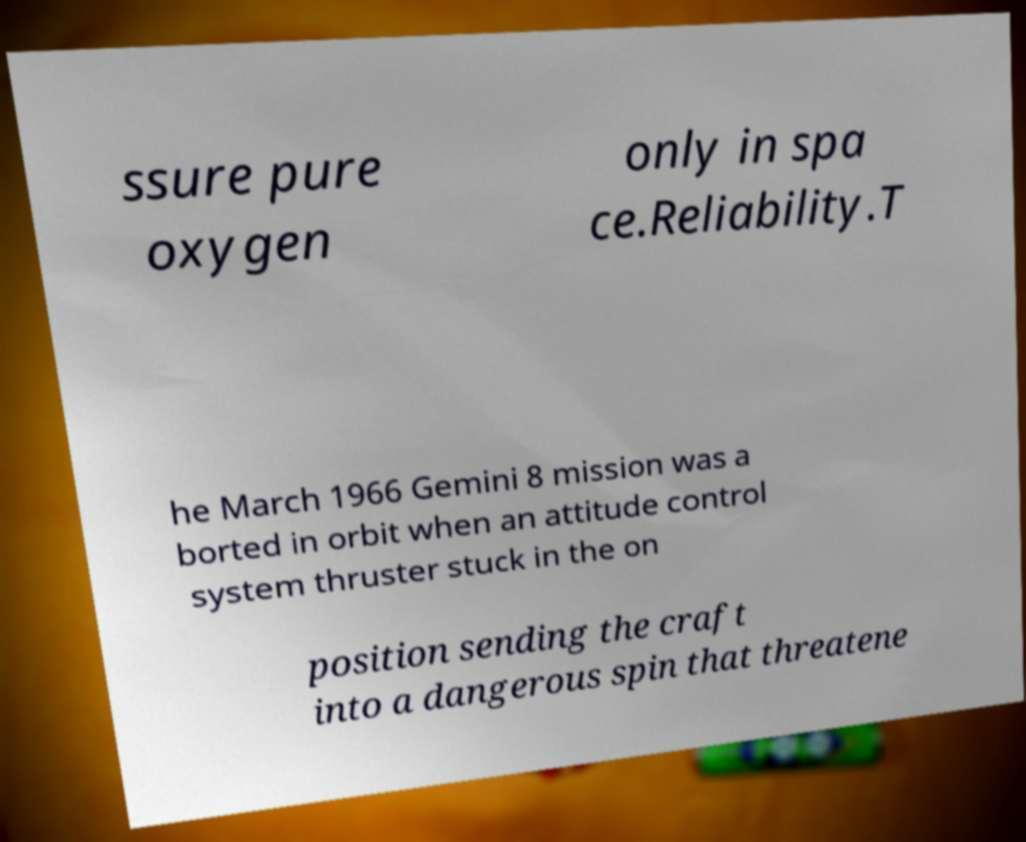There's text embedded in this image that I need extracted. Can you transcribe it verbatim? ssure pure oxygen only in spa ce.Reliability.T he March 1966 Gemini 8 mission was a borted in orbit when an attitude control system thruster stuck in the on position sending the craft into a dangerous spin that threatene 